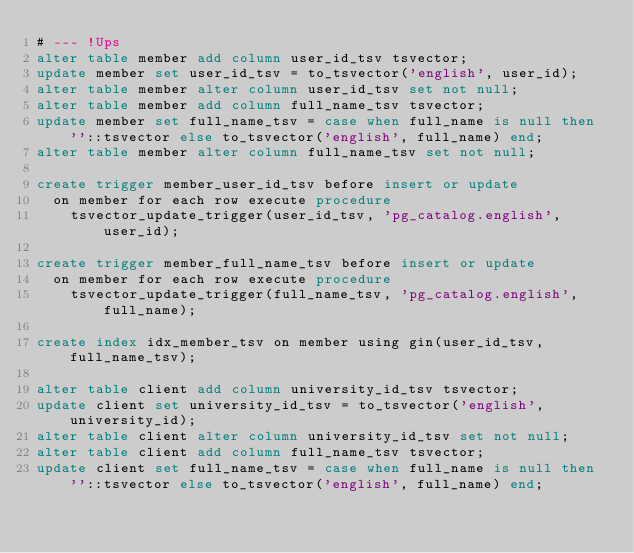<code> <loc_0><loc_0><loc_500><loc_500><_SQL_># --- !Ups
alter table member add column user_id_tsv tsvector;
update member set user_id_tsv = to_tsvector('english', user_id);
alter table member alter column user_id_tsv set not null;
alter table member add column full_name_tsv tsvector;
update member set full_name_tsv = case when full_name is null then ''::tsvector else to_tsvector('english', full_name) end;
alter table member alter column full_name_tsv set not null;

create trigger member_user_id_tsv before insert or update
  on member for each row execute procedure
    tsvector_update_trigger(user_id_tsv, 'pg_catalog.english', user_id);

create trigger member_full_name_tsv before insert or update
  on member for each row execute procedure
    tsvector_update_trigger(full_name_tsv, 'pg_catalog.english', full_name);

create index idx_member_tsv on member using gin(user_id_tsv, full_name_tsv);

alter table client add column university_id_tsv tsvector;
update client set university_id_tsv = to_tsvector('english', university_id);
alter table client alter column university_id_tsv set not null;
alter table client add column full_name_tsv tsvector;
update client set full_name_tsv = case when full_name is null then ''::tsvector else to_tsvector('english', full_name) end;</code> 